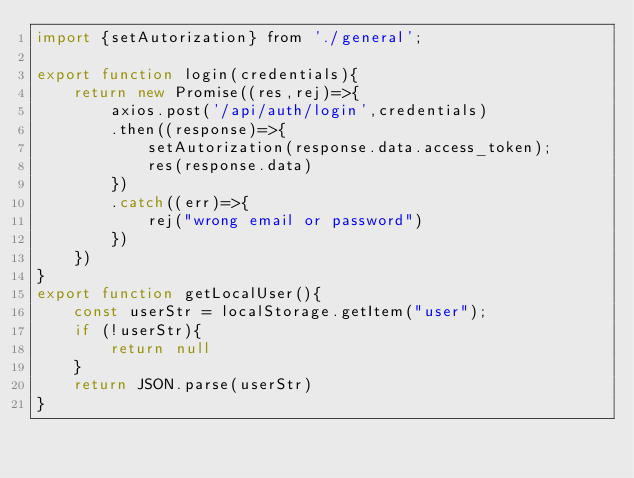Convert code to text. <code><loc_0><loc_0><loc_500><loc_500><_JavaScript_>import {setAutorization} from './general';

export function login(credentials){
    return new Promise((res,rej)=>{
        axios.post('/api/auth/login',credentials)
        .then((response)=>{
            setAutorization(response.data.access_token);
            res(response.data)
        })
        .catch((err)=>{
            rej("wrong email or password")
        })
    })
}
export function getLocalUser(){
    const userStr = localStorage.getItem("user");
    if (!userStr){
        return null
    }
    return JSON.parse(userStr)
}</code> 